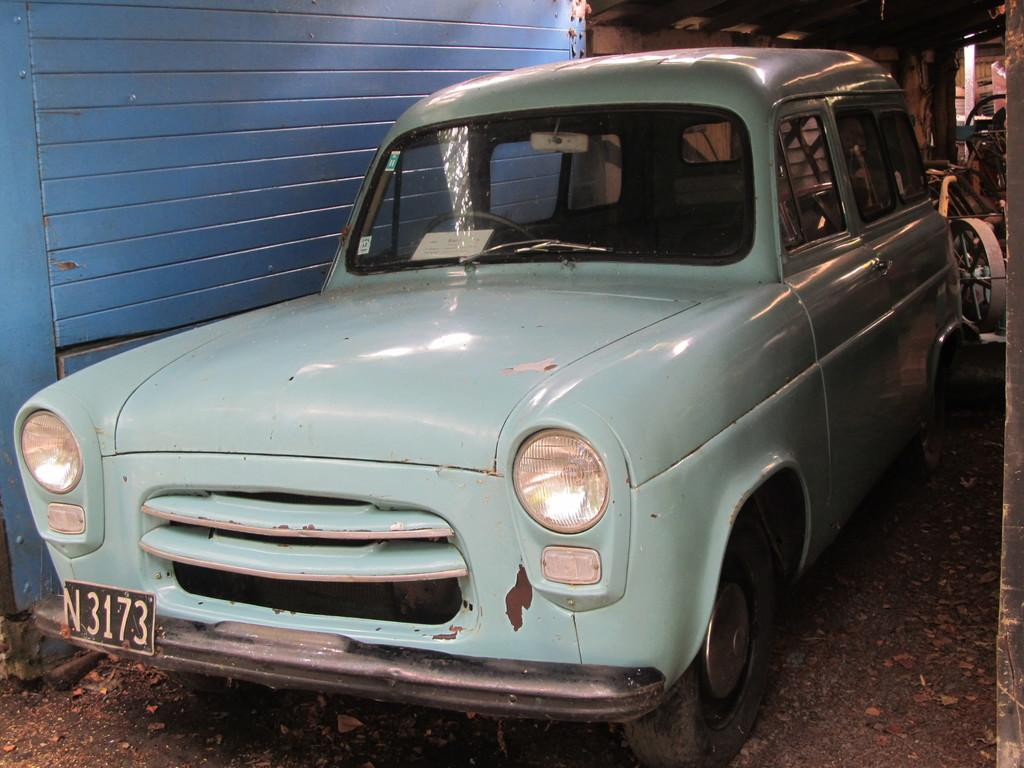What is the main subject of the picture? The main subject of the picture is a car. In which direction is the car facing? The car is facing towards the left. What color is the car? The car is light blue in color. How many babies are sitting inside the car in the image? There is no baby present in the image; it only shows a light blue car facing towards the left. 